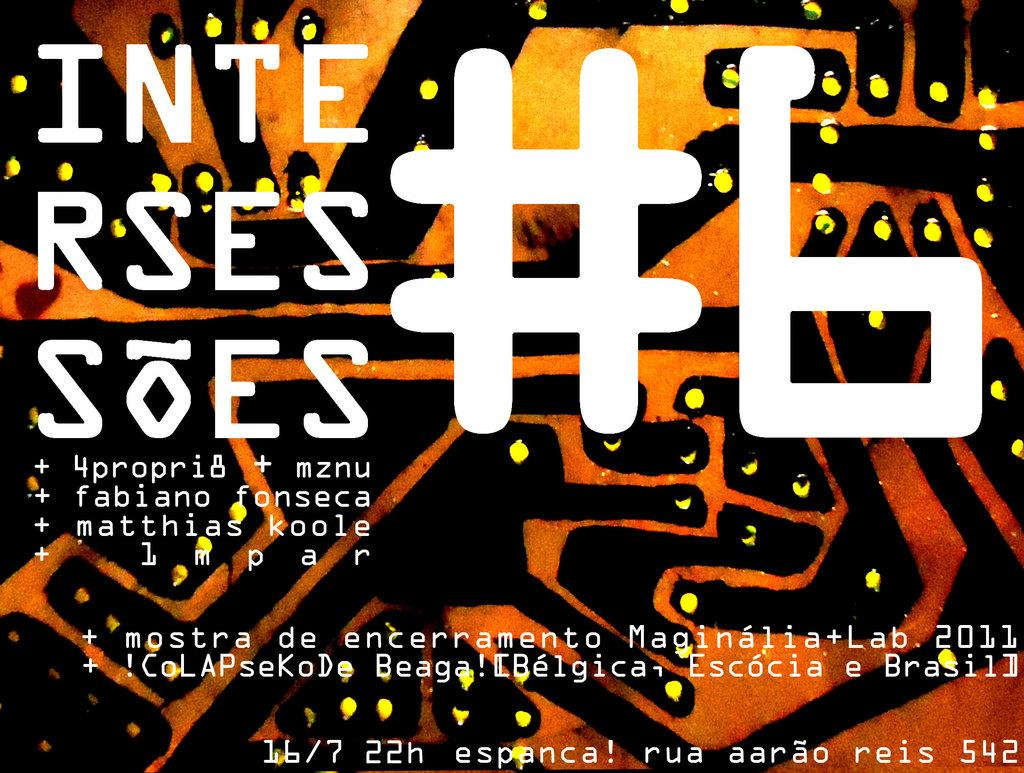What types of elements can be seen in the foreground of the poster? There are special characters, digits, and text in the foreground of the poster. Can you describe the special characters in the poster? Unfortunately, the specific appearance of the special characters cannot be described without more information. What do the digits in the poster represent? Without additional context, it is impossible to determine the meaning or significance of the digits in the poster. Is there a bridge visible in the poster? There is no mention of a bridge in the provided facts, so it cannot be determined if one is present in the poster. 